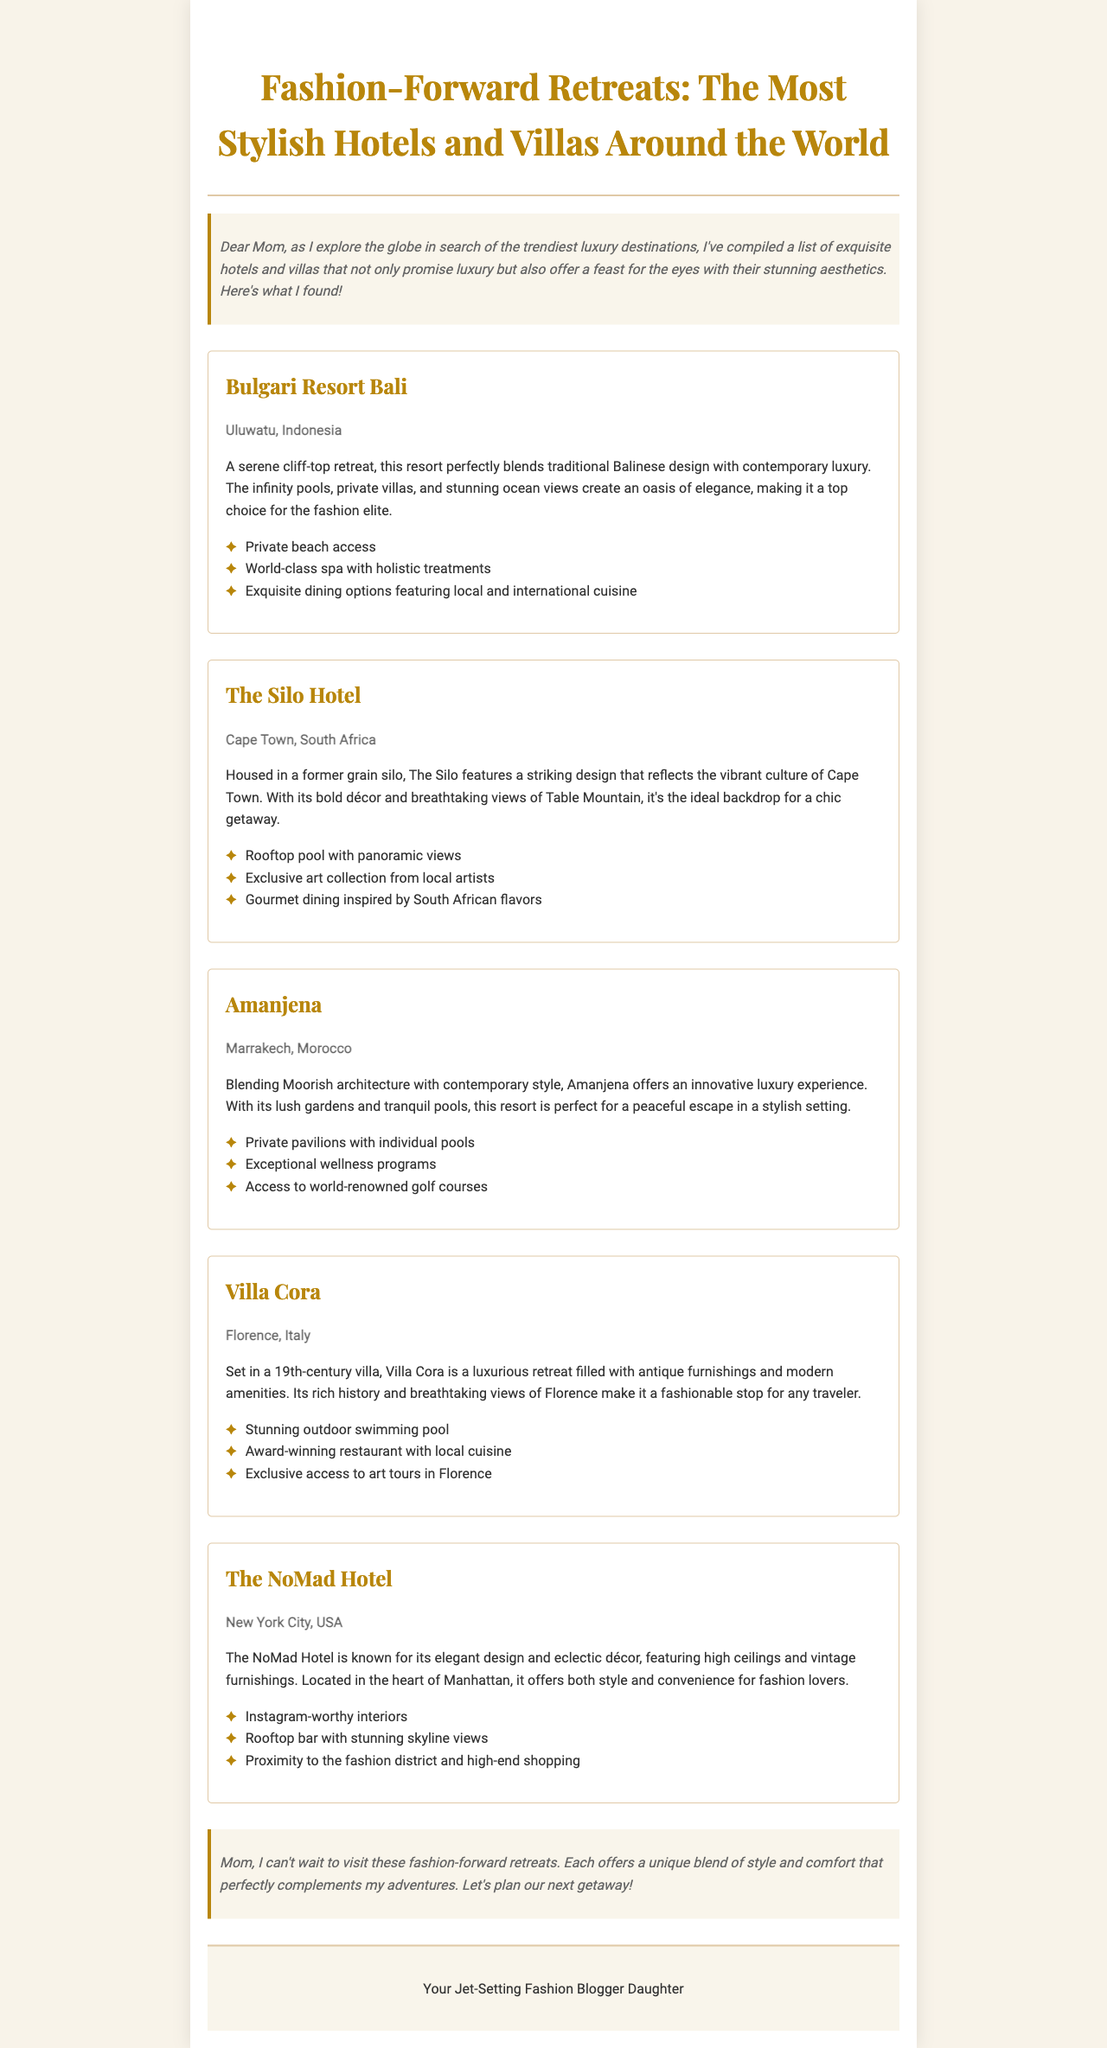What is the location of Bulgari Resort Bali? The location of Bulgari Resort Bali is mentioned in the document as Uluwatu, Indonesia.
Answer: Uluwatu, Indonesia What unique feature does The Silo Hotel offer? The document highlights that The Silo Hotel features a rooftop pool with panoramic views as a unique aspect of the hotel.
Answer: Rooftop pool with panoramic views Which hotel is set in a 19th-century villa? The document states that Villa Cora is set in a 19th-century villa, making it stand out among the other hotels listed.
Answer: Villa Cora How many hotels are mentioned in the newsletter? The document lists a total of five hotels and villas that are the focus of the newsletter.
Answer: Five What type of cuisine is offered at The NoMad Hotel? According to the document, The NoMad Hotel features gourmet dining inspired by South African flavors.
Answer: South African flavors Which destination offers private pavilions with individual pools? The document indicates that Amanjena offers private pavilions with individual pools as part of its luxurious amenities.
Answer: Amanjena What is a distinctive aesthetic of The Silo Hotel? The document describes The Silo Hotel as having a striking design that reflects the vibrant culture of Cape Town, indicating its distinctive aesthetic.
Answer: Striking design What does the newsletter refer to its author as? The document refers to the author as "Your Jet-Setting Fashion Blogger Daughter," highlighting the personal nature of the newsletter.
Answer: Your Jet-Setting Fashion Blogger Daughter 